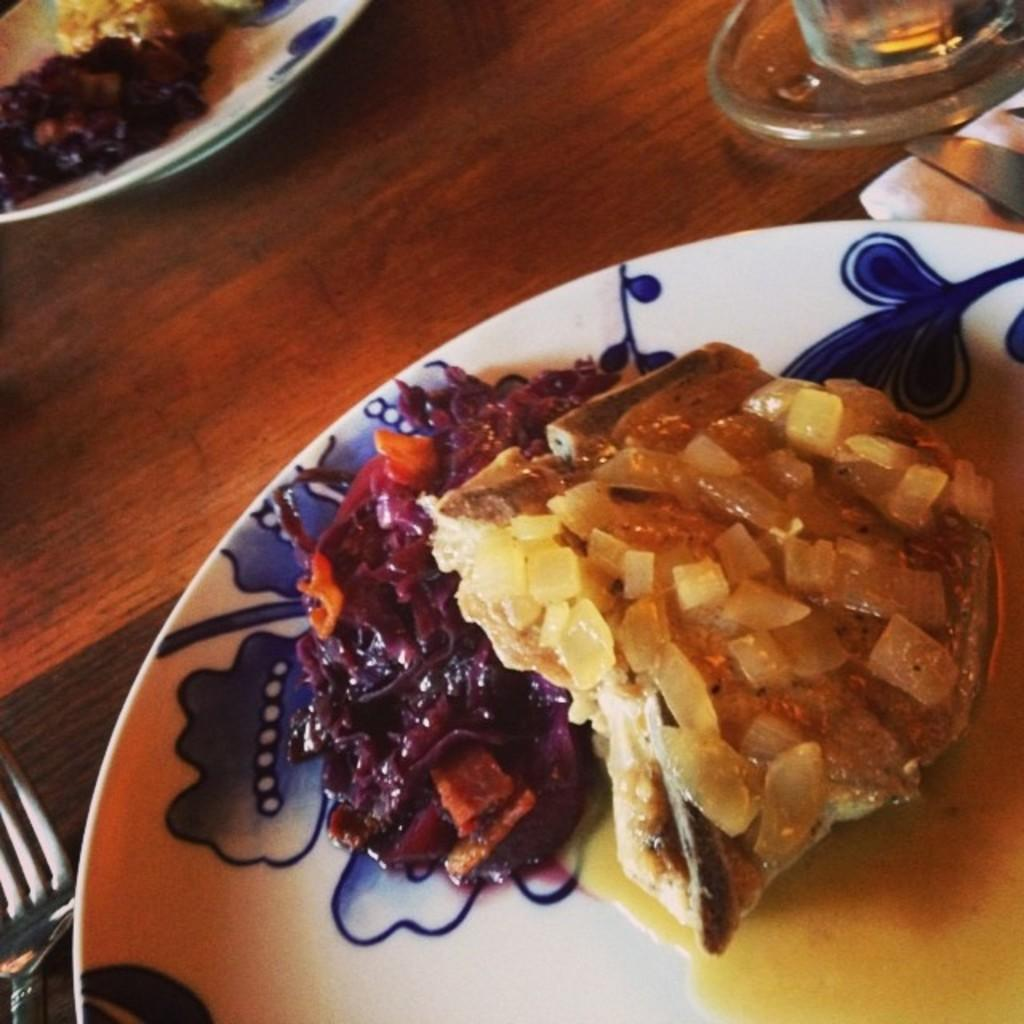What types of utensils are visible in the image? There are forks, knives, and spoons in the image. What type of dishware is present in the image? There are plates and glasses in the image. What type of material is the cloth made of? The cloth is made of a wooden material. What is the wooden object in the image used for? The wooden object is a table, which is used for holding the plates, glasses, and utensils. What food items can be seen on a plate in the image? There are food items on a plate in the image, but the specific type of food cannot be determined from the facts provided. How many toys are on the table in the image? There are no toys present in the image. What is the mother doing in the image? There is no mother present in the image. 